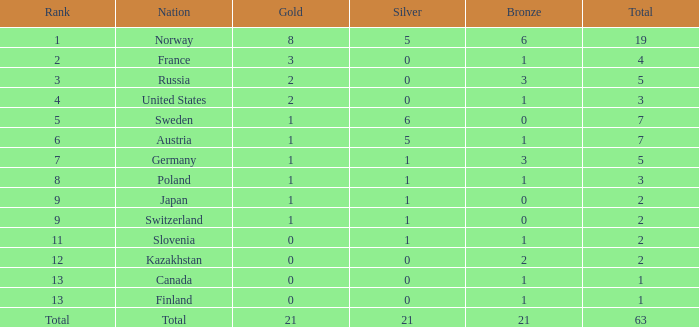Which rank has a gold value less than 1 and a silver value greater than 0? 11.0. 